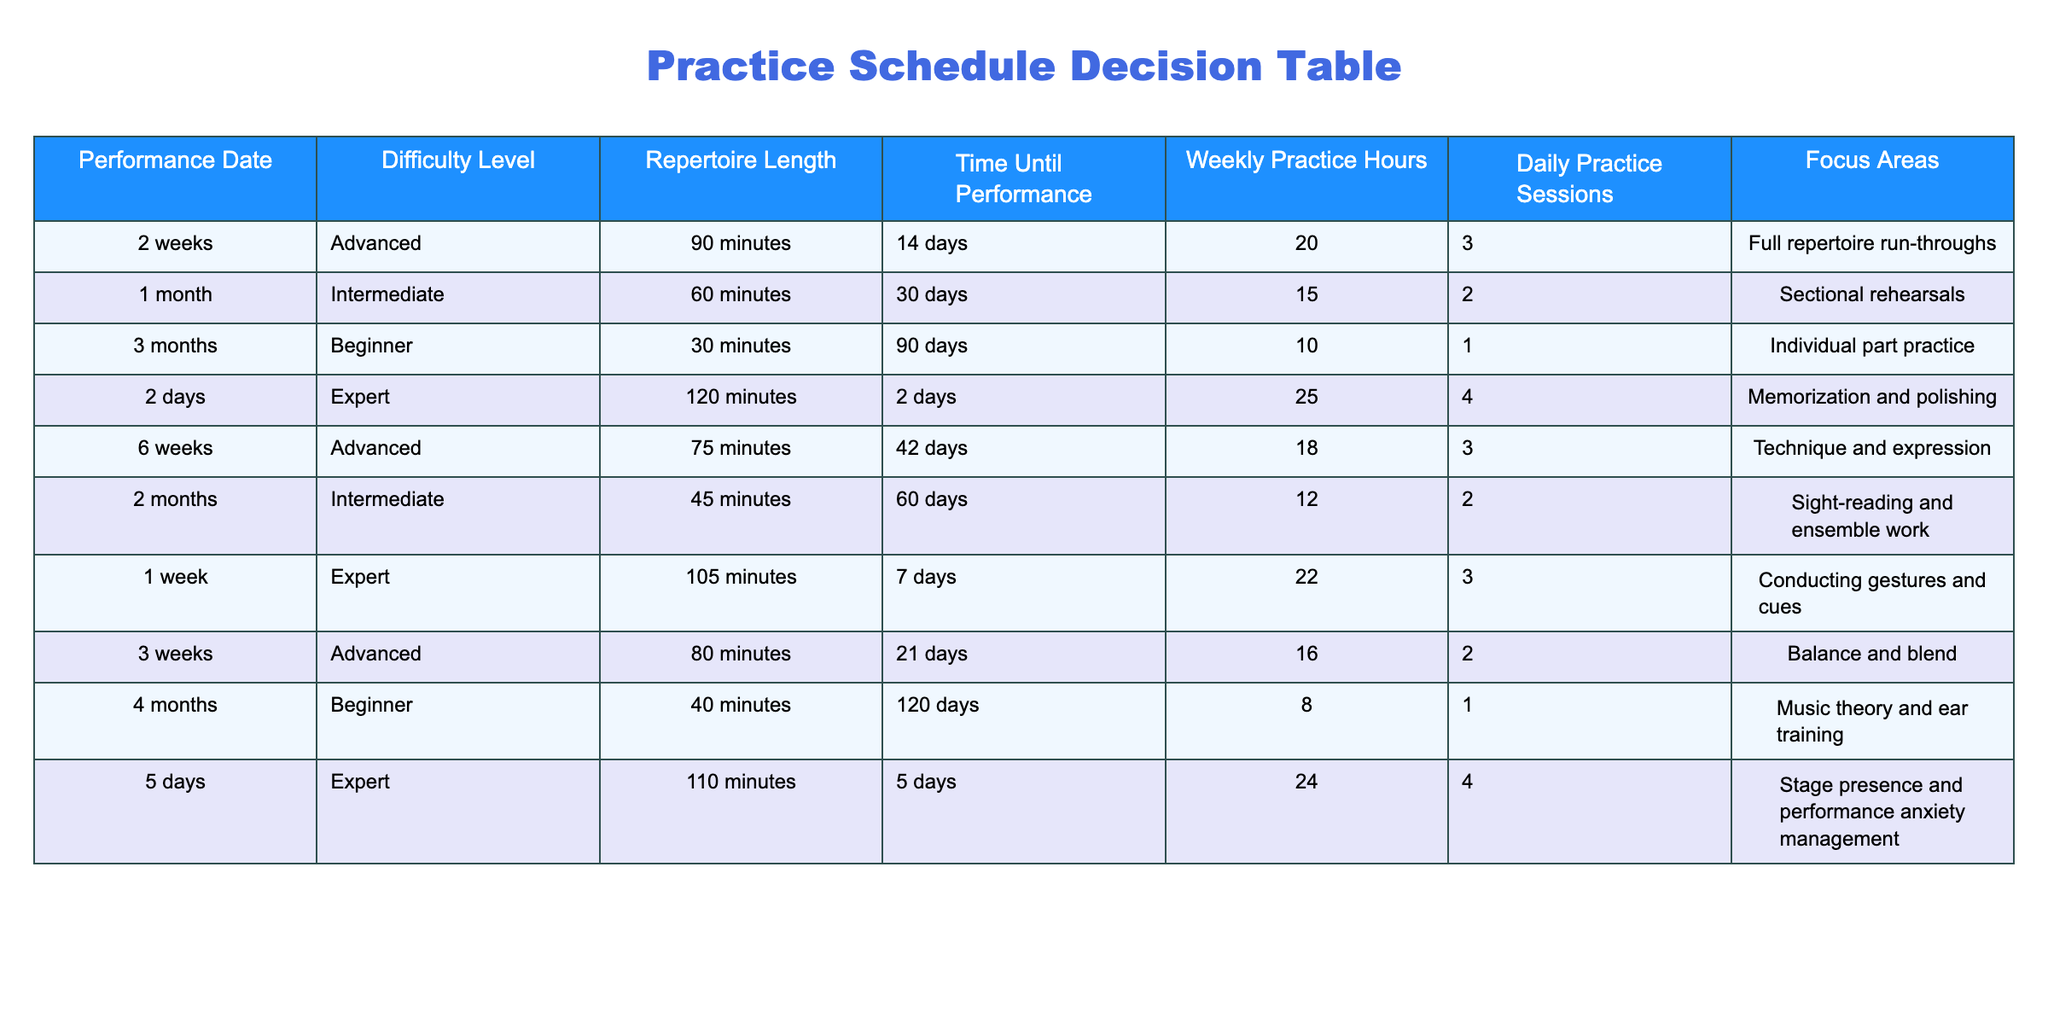What is the performance date for the piece with the longest repertoire length? The longest repertoire length is 120 minutes, which corresponds to the performance dated in 2 days.
Answer: 2 days How many weekly practice hours are required for an intermediate level repertoire? There are two entries for intermediate level: one at 15 weekly hours for 1 month and another at 12 hours for 2 months. Both entries confirm that the weekly practice hours are 15 and 12.
Answer: 15 and 12 Is there a performance that requires exactly 4 daily practice sessions? There are two entries for expert level performance: one with 4 daily practice sessions and another with 4 daily practices as well. Therefore, the answer is yes.
Answer: Yes What is the total time until performance across all pieces requiring advanced difficulty? The advanced difficulty pieces have the following time until performance: 14 days, 42 days, 21 days, totaling 77 days.
Answer: 77 days Which focus area is common for expert level performances? Both expert performances emphasize stage presence and performance anxiety management as well as memorization and polishing, indicating a common focus area.
Answer: Yes How does the average repertoire length of beginner pieces compare to that of advanced pieces? The beginner pieces have repertoire lengths of 30 minutes and 40 minutes, averaging 35 minutes. The advanced pieces average 86.25 minutes. Thus, the beginner pieces are shorter.
Answer: Beginner pieces are shorter What is the relationship between the difficulty level and the required practice hours for a performance in 6 weeks? The performance in 6 weeks has an advanced difficulty level and requires 18 weekly practice hours; this indicates a correlation between advanced difficulty and higher practice hours than beginner or intermediate levels.
Answer: Higher practice hours for advanced difficulty Are there more expert level performances than beginner level performances in the table? The table has three expert level performances and two beginner level performances. Therefore, there are indeed more expert level performances.
Answer: Yes What is the difference in practice hours between the longest and shortest repertoire lengths? The shortest repertoire length is 30 minutes and the longest is 120 minutes with practice hours recorded as 10 and 25 respectively, making the difference in practice hours 25 - 10 = 15.
Answer: 15 What focus area is unique to the performance scheduled in one week? The focus area for the performance scheduled in one week is "Conducting gestures and cues," which is not listed for any other performances in the table.
Answer: Conducting gestures and cues 